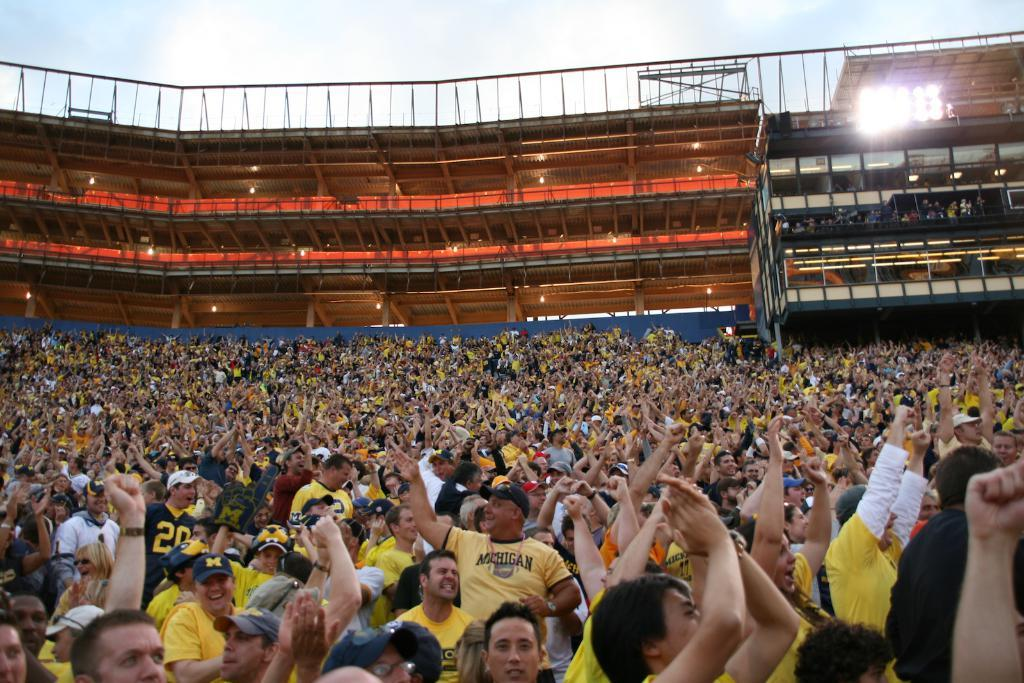What are the people in the image doing? The groups of people are standing in the image. Where might this image have been taken? The location appears to be a stadium. What can be seen in the background of the image? There are buildings visible in the background. What is visible in the sky? The sky is visible in the image. What type of yoke is being used by the people in the image? There is no yoke present in the image; it features groups of people standing in a stadium. What type of suit is the stadium wearing in the image? The stadium is not a living being and therefore cannot wear a suit. 